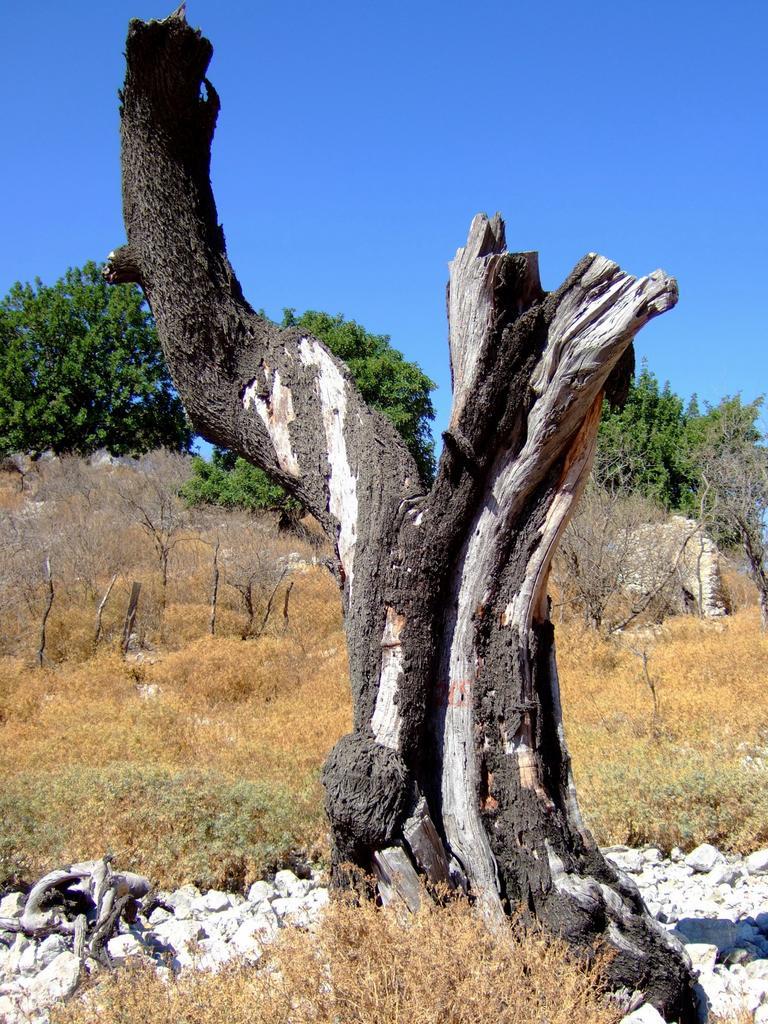Could you give a brief overview of what you see in this image? In this image we can see the trees, grass and also the stones. In the center we can see the bark of a tree. We can also see the sky in the background. 